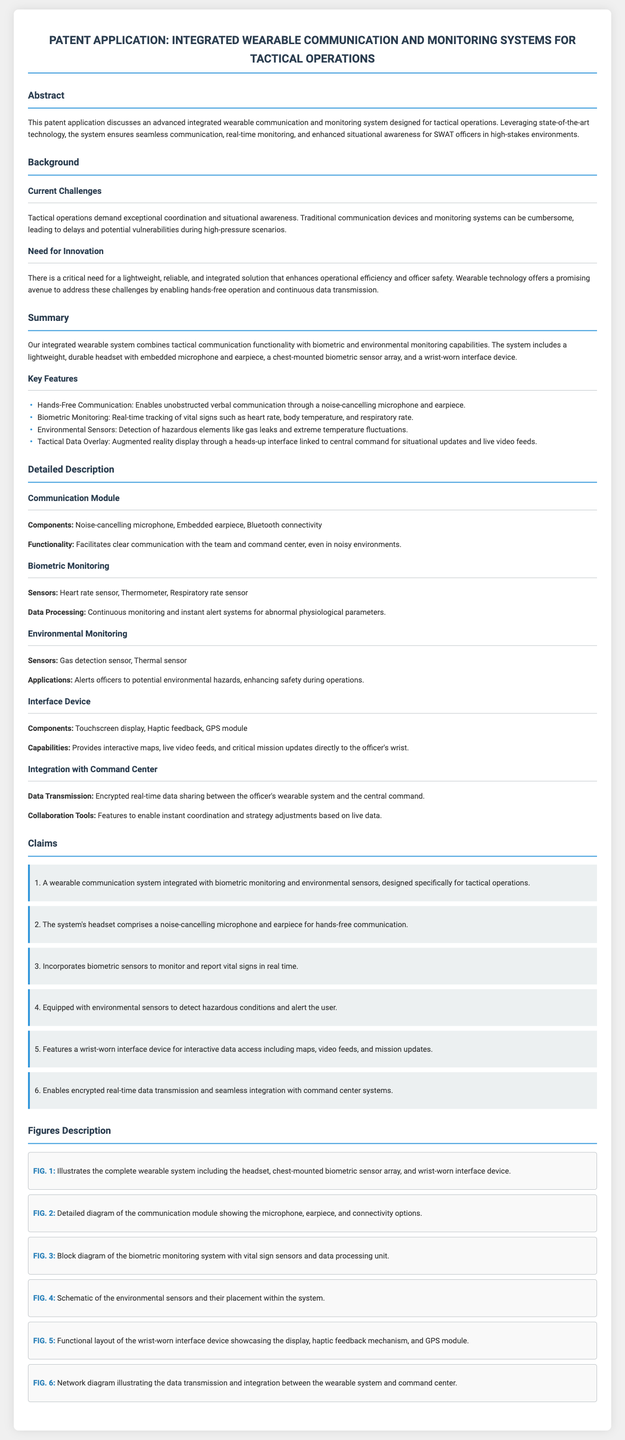What is the primary purpose of the patent application? The patent application discusses an advanced integrated wearable communication and monitoring system designed for tactical operations.
Answer: Seamless communication, real-time monitoring, and enhanced situational awareness What does the system include for monitoring vital signs? The system incorporates sensors specifically designed for tracking vital signs.
Answer: Biometric sensor array Which feature enables unobstructed verbal communication? A specific component is designed to facilitate clear communication even in noisy environments.
Answer: Noise-cancelling microphone and earpiece What type of display is featured on the wrist-worn device? The wrist-worn device has a specific type of display that provides interactive information.
Answer: Touchscreen display How many claims are there in the patent application? The number of claims listed provides insight into the intellectual property being protected.
Answer: Six What is one key feature that enhances officer safety? The system includes a specific functionality aimed at detecting potential hazards.
Answer: Environmental sensors What does FIG. 1 illustrate? The figures provide visual representation of various components and their relation within the system.
Answer: Complete wearable system What type of data transmission is mentioned in the document? The patent specifies the nature of data sharing between the wearable system and the command center.
Answer: Encrypted real-time data sharing What is the purpose of the haptic feedback in the interface device? The feedback mechanism is intended to provide specific user interactions within the interface.
Answer: Interaction feedback 